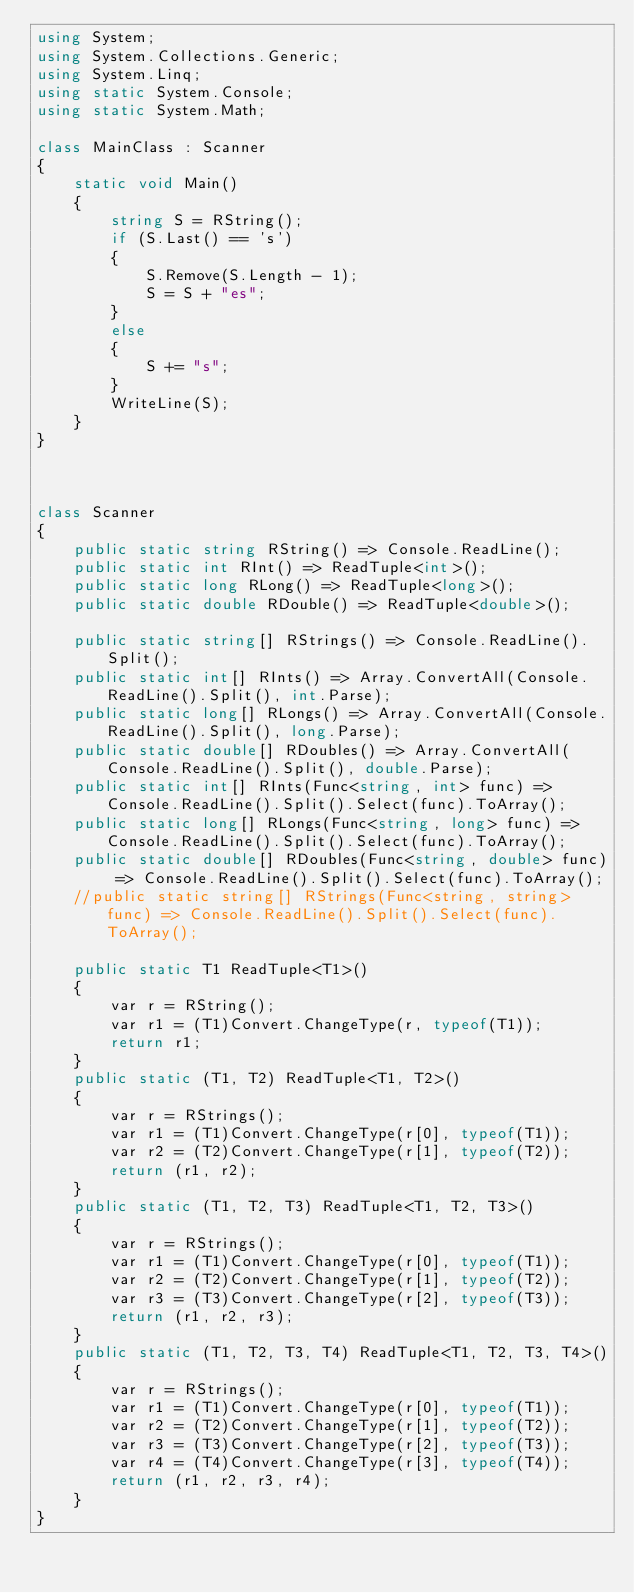<code> <loc_0><loc_0><loc_500><loc_500><_C#_>using System;
using System.Collections.Generic;
using System.Linq;
using static System.Console;
using static System.Math;

class MainClass : Scanner
{
    static void Main()
    {
        string S = RString();
        if (S.Last() == 's')
        {
            S.Remove(S.Length - 1);
            S = S + "es";
        }
        else
        {
            S += "s";
        }
        WriteLine(S);
    }
}



class Scanner
{
    public static string RString() => Console.ReadLine();
    public static int RInt() => ReadTuple<int>();
    public static long RLong() => ReadTuple<long>();
    public static double RDouble() => ReadTuple<double>();

    public static string[] RStrings() => Console.ReadLine().Split();
    public static int[] RInts() => Array.ConvertAll(Console.ReadLine().Split(), int.Parse);
    public static long[] RLongs() => Array.ConvertAll(Console.ReadLine().Split(), long.Parse);
    public static double[] RDoubles() => Array.ConvertAll(Console.ReadLine().Split(), double.Parse);
    public static int[] RInts(Func<string, int> func) => Console.ReadLine().Split().Select(func).ToArray();
    public static long[] RLongs(Func<string, long> func) => Console.ReadLine().Split().Select(func).ToArray();
    public static double[] RDoubles(Func<string, double> func) => Console.ReadLine().Split().Select(func).ToArray();
    //public static string[] RStrings(Func<string, string> func) => Console.ReadLine().Split().Select(func).ToArray();

    public static T1 ReadTuple<T1>()
    {
        var r = RString();
        var r1 = (T1)Convert.ChangeType(r, typeof(T1));
        return r1;
    }
    public static (T1, T2) ReadTuple<T1, T2>()
    {
        var r = RStrings();
        var r1 = (T1)Convert.ChangeType(r[0], typeof(T1));
        var r2 = (T2)Convert.ChangeType(r[1], typeof(T2));
        return (r1, r2);
    }
    public static (T1, T2, T3) ReadTuple<T1, T2, T3>()
    {
        var r = RStrings();
        var r1 = (T1)Convert.ChangeType(r[0], typeof(T1));
        var r2 = (T2)Convert.ChangeType(r[1], typeof(T2));
        var r3 = (T3)Convert.ChangeType(r[2], typeof(T3));
        return (r1, r2, r3);
    }
    public static (T1, T2, T3, T4) ReadTuple<T1, T2, T3, T4>()
    {
        var r = RStrings();
        var r1 = (T1)Convert.ChangeType(r[0], typeof(T1));
        var r2 = (T2)Convert.ChangeType(r[1], typeof(T2));
        var r3 = (T3)Convert.ChangeType(r[2], typeof(T3));
        var r4 = (T4)Convert.ChangeType(r[3], typeof(T4));
        return (r1, r2, r3, r4);
    }
}
</code> 